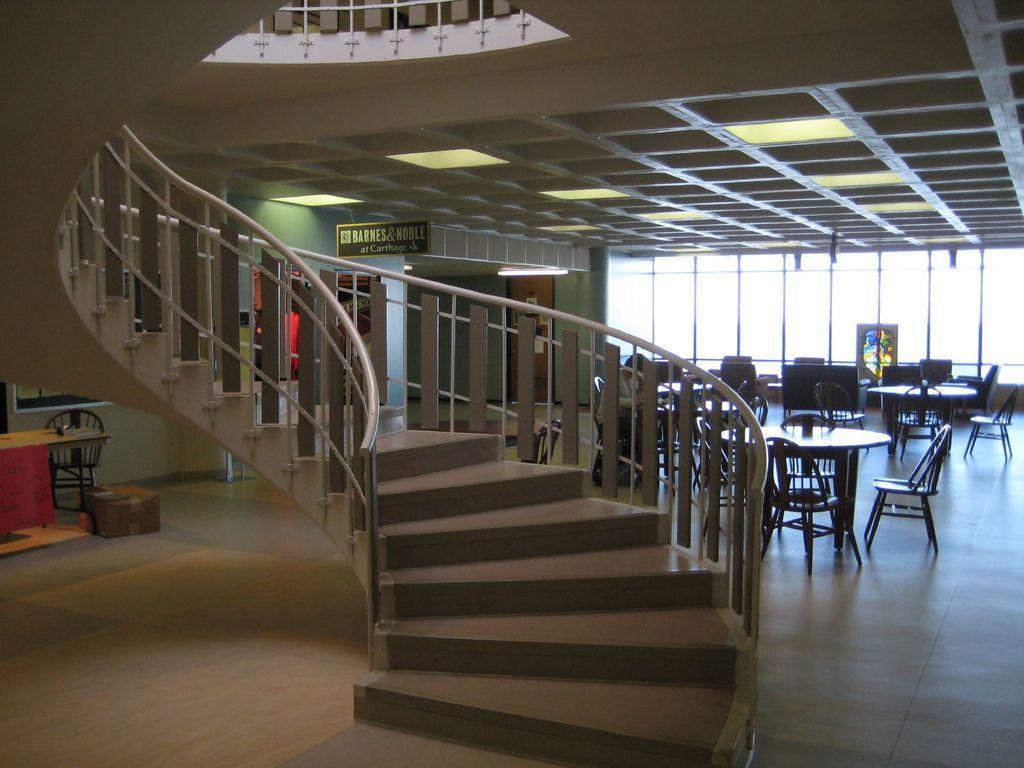How would you summarize this image in a sentence or two? In this picture I can see stars, there are tables, chairs, boards, lights, there is a cardboard box and there are some objects. 